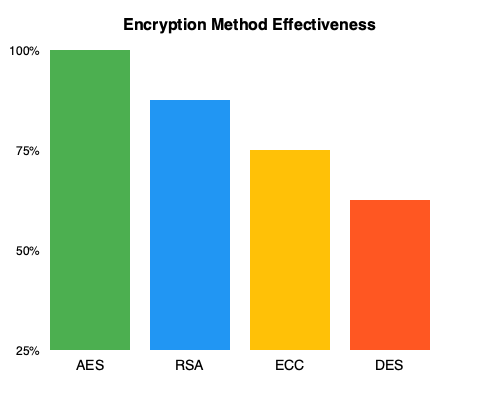Based on the bar chart showing the effectiveness of different encryption methods, which method appears to be the most secure, and how does it compare to the least secure method in terms of percentage difference? To answer this question, we need to analyze the bar chart and follow these steps:

1. Identify the encryption methods: The chart shows four methods - AES, RSA, ECC, and DES.

2. Determine the most secure method: The tallest bar represents the most effective (secure) method. In this case, it's AES with a 100% effectiveness.

3. Identify the least secure method: The shortest bar represents the least effective method, which is DES with approximately 50% effectiveness.

4. Calculate the percentage difference:
   - AES effectiveness: 100%
   - DES effectiveness: 50%
   - Difference: 100% - 50% = 50%

5. Express the difference as a percentage:
   (Difference / Least secure method's effectiveness) * 100
   = (50% / 50%) * 100 = 100%

Therefore, AES is the most secure method, and it is 100% more effective than DES, the least secure method.
Answer: AES; 100% more effective than DES 